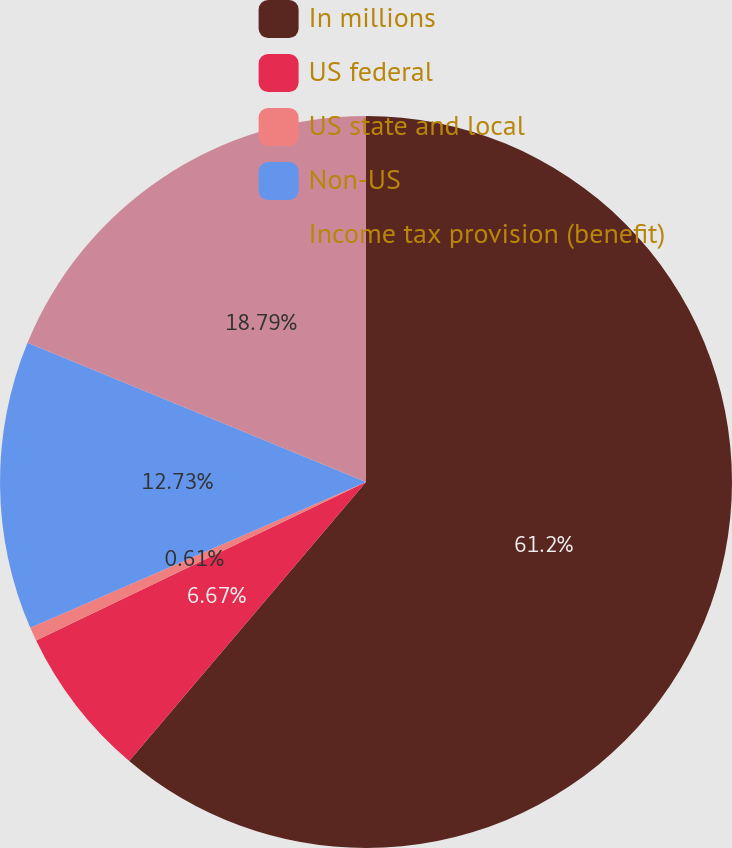Convert chart. <chart><loc_0><loc_0><loc_500><loc_500><pie_chart><fcel>In millions<fcel>US federal<fcel>US state and local<fcel>Non-US<fcel>Income tax provision (benefit)<nl><fcel>61.2%<fcel>6.67%<fcel>0.61%<fcel>12.73%<fcel>18.79%<nl></chart> 